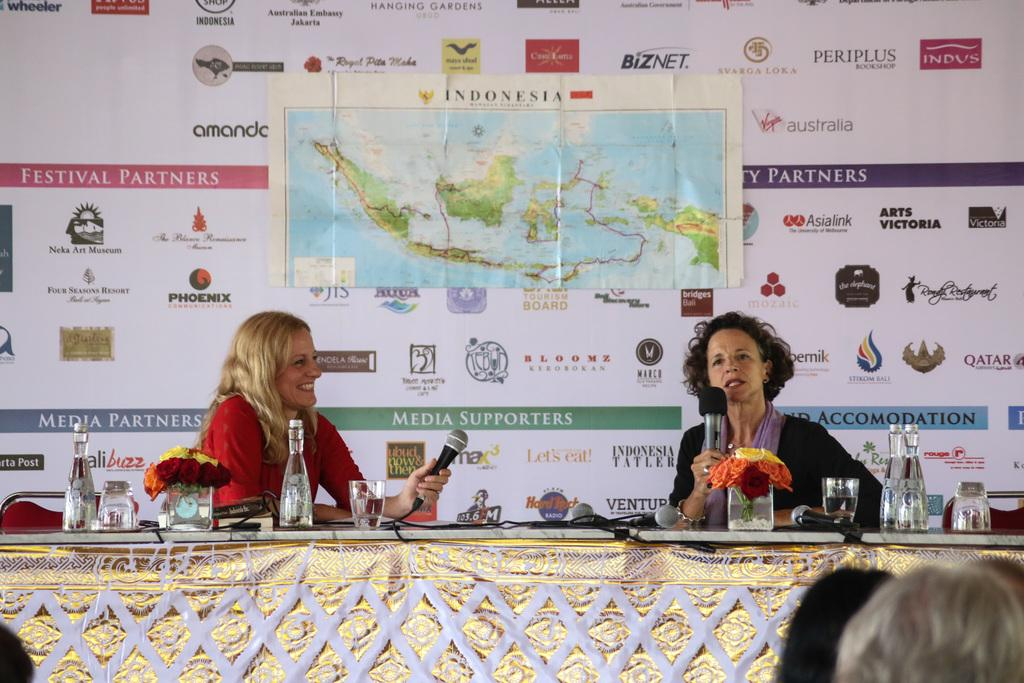How many people are in the image? There are people in the image, but the exact number is not specified. What can be seen hanging in the image? There are banners in the image. What are two persons doing in the image? Two persons are holding microphones. What is present on the table in the image? There are glasses, flowers, and bottles on the table. How many clocks are visible on the table in the image? There are no clocks visible on the table in the image. What type of machine is being used by the people in the image? There is no machine present in the image; the people are holding microphones. 